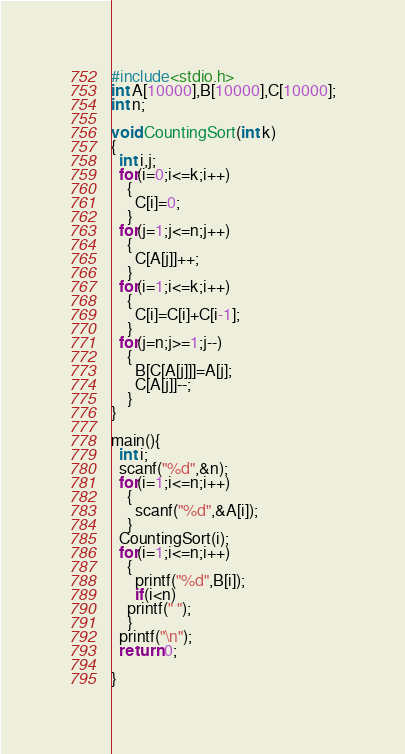<code> <loc_0><loc_0><loc_500><loc_500><_C_>#include<stdio.h>
int A[10000],B[10000],C[10000];
int n;

void CountingSort(int k)
{
  int i,j;
  for(i=0;i<=k;i++)
    {
      C[i]=0;
    }
  for(j=1;j<=n;j++)
    {
      C[A[j]]++;
    }
  for(i=1;i<=k;i++)
    {
      C[i]=C[i]+C[i-1];
    }
  for(j=n;j>=1;j--)
    {
      B[C[A[j]]]=A[j];
      C[A[j]]--;
    }
}

main(){
  int i;
  scanf("%d",&n);
  for(i=1;i<=n;i++)
    {
      scanf("%d",&A[i]);
    }
  CountingSort(i);
  for(i=1;i<=n;i++)
    {
      printf("%d",B[i]);
      if(i<n)
	printf(" ");
    }
  printf("\n");
  return 0;

}</code> 